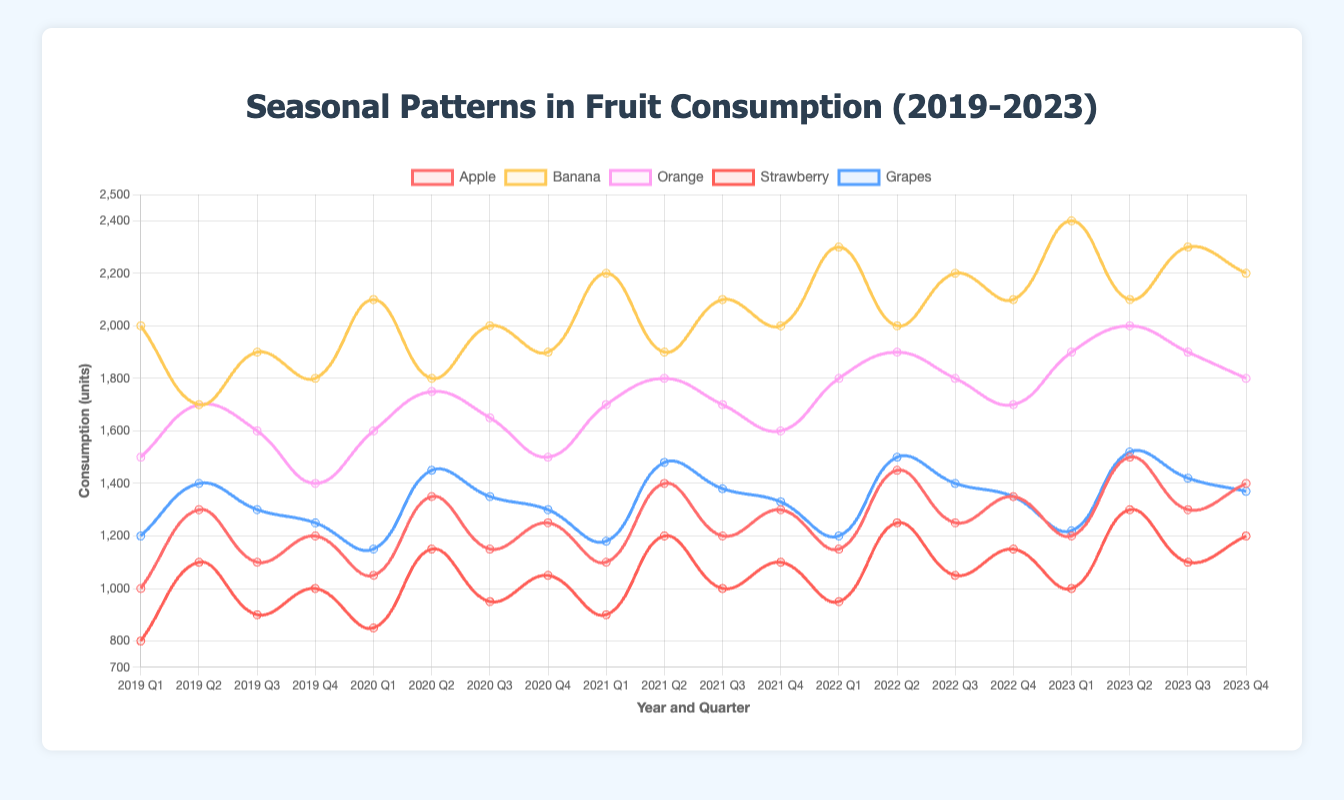What is the peak consumption quarter for bananas over the past 5 years? To determine this, locate the quarter with the highest data point in the banana line on the figure. The highest value occurs in Q1 2023 with 2400 units.
Answer: Q1 2023 Which fruit had the most stable consumption pattern over the 5 years? Look for the fruit line with the least fluctuation in height. The grapes line shows the least variability in height, indicating a more stable consumption pattern.
Answer: Grapes In which year did oranges experience the highest consumption during a single quarter? Find the highest data point in the oranges line and identify the corresponding year. The highest consumption of oranges occurred in Q2 2023 with 2000 units.
Answer: 2023 What is the total consumption of strawberries in all Q2 quarters combined? Sum the strawberry values from all Q2 quarters: 1100 (2019) + 1150 (2020) + 1200 (2021) + 1250 (2022) + 1300 (2023) = 6000 units.
Answer: 6000 Compare the apple consumption in Q1 2019 and Q1 2023. Which quarter had higher consumption and by how much? Apple consumption in Q1 2019 is 1000 units and in Q1 2023, it's 1200 units. Q1 2023 had higher consumption by 200 units.
Answer: Q1 2023, 200 units What is the average consumption of bananas during the Q3 quarters from 2019 to 2023? Banana values in Q3 quarters are: 1900 (2019), 2000 (2020), 2100 (2021), 2200 (2022), 2300 (2023). The average is (1900 + 2000 + 2100 + 2200 + 2300) / 5 = 2100 units.
Answer: 2100 How does the consumption of oranges in Q4 2023 compare to Q4 2022? Oranges in Q4 2023 are consumed at 1800 units; in Q4 2022, it's 1700 units. Q4 2023 shows an increase of 100 units compared to Q4 2022.
Answer: 100 units more Identify the quarter with the lowest strawberry consumption and provide the value. The lowest strawberry consumption is seen in Q1 2019 with 800 units.
Answer: Q1 2019, 800 units What is the highest single consumption value for apples within the dataset? Find the highest peak in the apple line. The maximum is 1500 units which occurs in Q2 2023.
Answer: 1500 